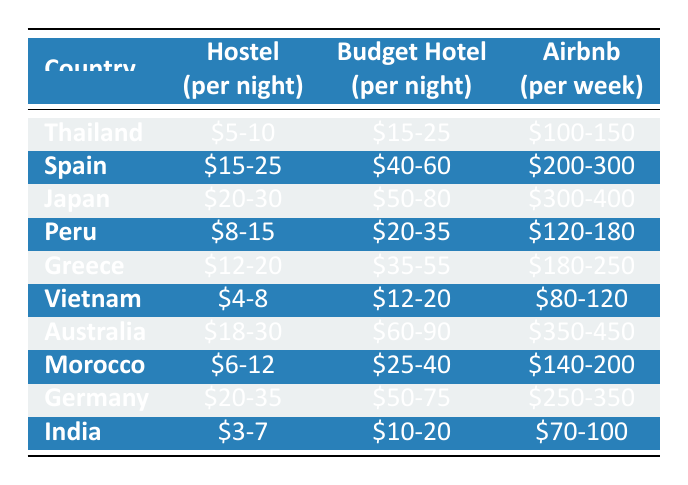What is the cheapest option for accommodation in India? The table shows that in India, the hostel costs between $3-7 per night, which is less than both the budget hotel ($10-20) and the Airbnb option ($70-100 per week). Therefore, the cheapest option is the hostel.
Answer: $3-7 Which country has the highest weekly Airbnb cost? From examining the table, Japan has the highest Airbnb cost listed at $300-400 per week, which is higher than the other countries listed.
Answer: $300-400 What is the difference in cost for budget hotels between Spain and Thailand? Budget hotels in Spain cost between $40-60 per night, while in Thailand, they range from $15-25 per night. To find the difference, we recognize that the maximum for Spain ($60) minus the minimum for Thailand ($15) equals $45, and the minimum for Spain ($40) minus the maximum for Thailand ($25) equals $15. The overall difference will be $45 and $15.
Answer: $15 to $45 Is the hostel price in Vietnam lower than that in Greece? The hostel price in Vietnam is listed as $4-8, whereas in Greece, it ranges from $12-20. Since $4 is less than $12, the hostel in Vietnam is indeed lower than in Greece.
Answer: Yes What is the average price for hostels in all listed countries? To calculate the average hostel price, we first identify the minimum and maximum prices for each country: Thailand ($5-10), Spain ($15-25), Japan ($20-30), Peru ($8-15), Greece ($12-20), Vietnam ($4-8), Australia ($18-30), Morocco ($6-12), Germany ($20-35), and India ($3-7). By taking the averages: (7.5 + 20 + 25 + 11.5 + 16 + 6 + 24 + 9 + 27.5 + 5) / 10 = 14.5, we find that the average price is approximately $14.5.
Answer: $14.5 